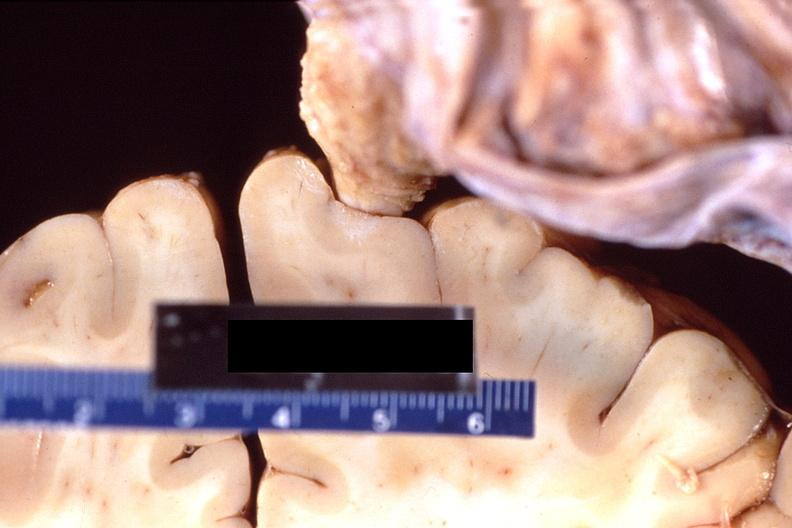what does this image show?
Answer the question using a single word or phrase. Brain 